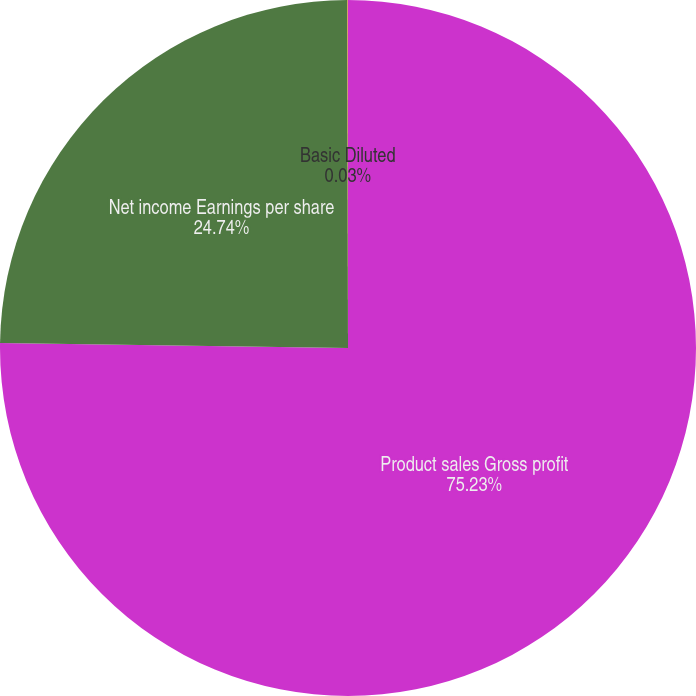Convert chart to OTSL. <chart><loc_0><loc_0><loc_500><loc_500><pie_chart><fcel>Product sales Gross profit<fcel>Net income Earnings per share<fcel>Basic Diluted<nl><fcel>75.24%<fcel>24.74%<fcel>0.03%<nl></chart> 